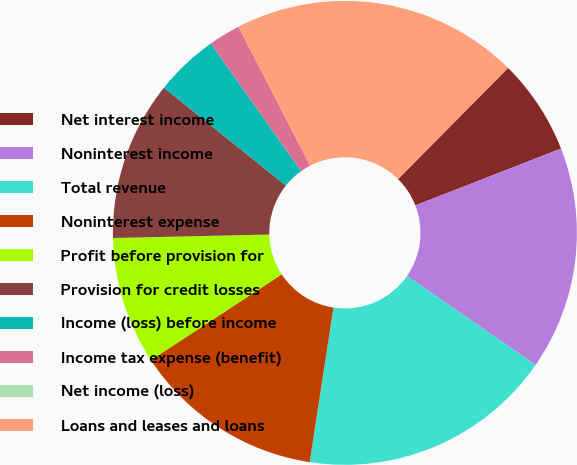Convert chart. <chart><loc_0><loc_0><loc_500><loc_500><pie_chart><fcel>Net interest income<fcel>Noninterest income<fcel>Total revenue<fcel>Noninterest expense<fcel>Profit before provision for<fcel>Provision for credit losses<fcel>Income (loss) before income<fcel>Income tax expense (benefit)<fcel>Net income (loss)<fcel>Loans and leases and loans<nl><fcel>6.67%<fcel>15.56%<fcel>17.78%<fcel>13.33%<fcel>8.89%<fcel>11.11%<fcel>4.44%<fcel>2.22%<fcel>0.0%<fcel>20.0%<nl></chart> 